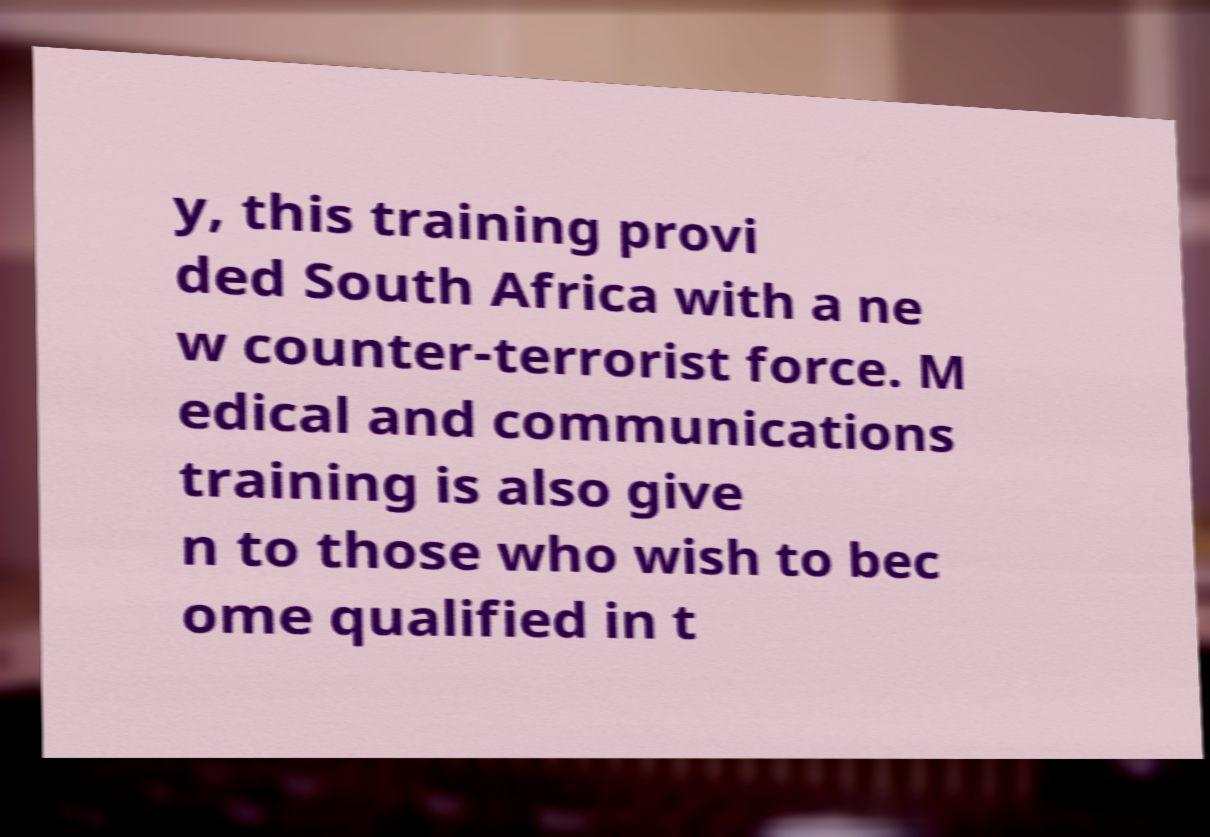Please read and relay the text visible in this image. What does it say? y, this training provi ded South Africa with a ne w counter-terrorist force. M edical and communications training is also give n to those who wish to bec ome qualified in t 